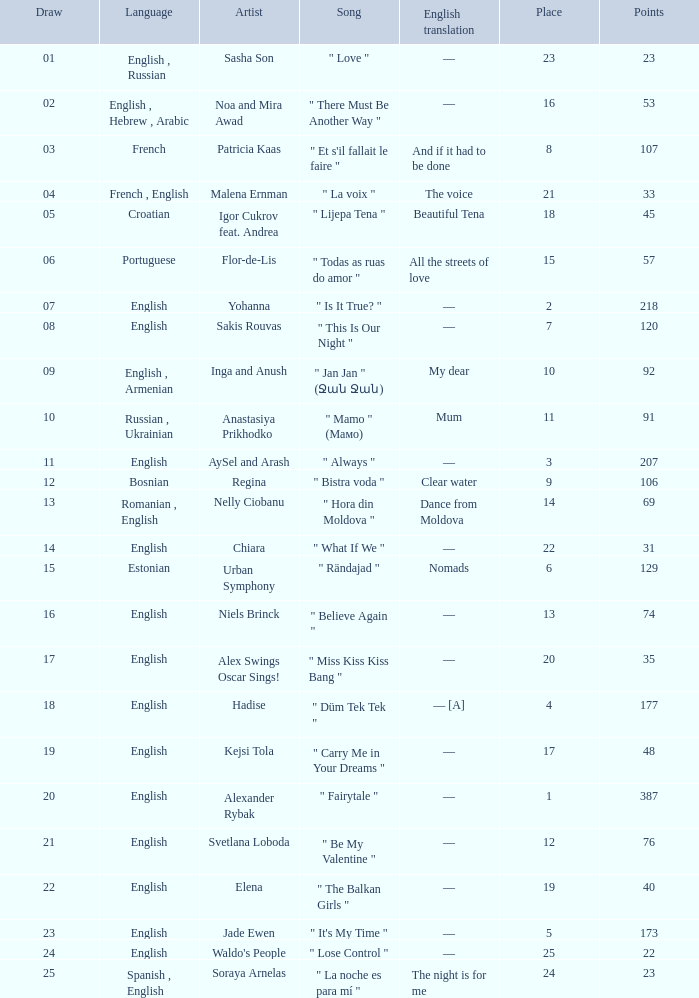What was the average place for the song that had 69 points and a draw smaller than 13? None. 